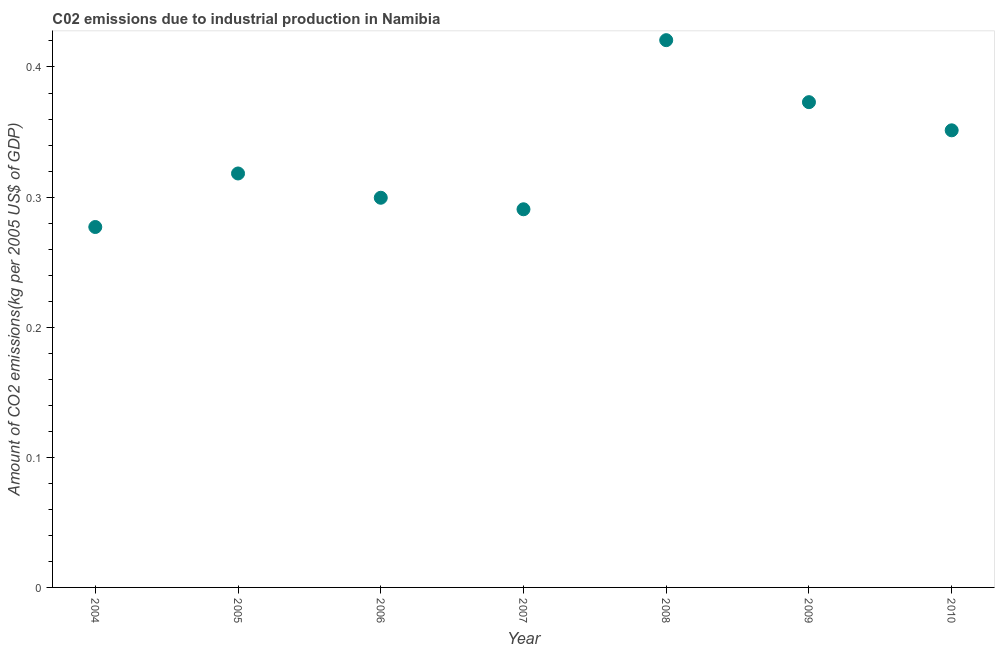What is the amount of co2 emissions in 2007?
Provide a succinct answer. 0.29. Across all years, what is the maximum amount of co2 emissions?
Provide a short and direct response. 0.42. Across all years, what is the minimum amount of co2 emissions?
Your response must be concise. 0.28. In which year was the amount of co2 emissions maximum?
Keep it short and to the point. 2008. In which year was the amount of co2 emissions minimum?
Give a very brief answer. 2004. What is the sum of the amount of co2 emissions?
Your answer should be compact. 2.33. What is the difference between the amount of co2 emissions in 2004 and 2009?
Your answer should be very brief. -0.1. What is the average amount of co2 emissions per year?
Your answer should be very brief. 0.33. What is the median amount of co2 emissions?
Offer a terse response. 0.32. What is the ratio of the amount of co2 emissions in 2004 to that in 2007?
Your answer should be very brief. 0.95. What is the difference between the highest and the second highest amount of co2 emissions?
Offer a very short reply. 0.05. Is the sum of the amount of co2 emissions in 2004 and 2005 greater than the maximum amount of co2 emissions across all years?
Offer a terse response. Yes. What is the difference between the highest and the lowest amount of co2 emissions?
Your answer should be very brief. 0.14. Does the amount of co2 emissions monotonically increase over the years?
Provide a succinct answer. No. What is the title of the graph?
Keep it short and to the point. C02 emissions due to industrial production in Namibia. What is the label or title of the Y-axis?
Keep it short and to the point. Amount of CO2 emissions(kg per 2005 US$ of GDP). What is the Amount of CO2 emissions(kg per 2005 US$ of GDP) in 2004?
Your answer should be compact. 0.28. What is the Amount of CO2 emissions(kg per 2005 US$ of GDP) in 2005?
Make the answer very short. 0.32. What is the Amount of CO2 emissions(kg per 2005 US$ of GDP) in 2006?
Offer a very short reply. 0.3. What is the Amount of CO2 emissions(kg per 2005 US$ of GDP) in 2007?
Make the answer very short. 0.29. What is the Amount of CO2 emissions(kg per 2005 US$ of GDP) in 2008?
Your response must be concise. 0.42. What is the Amount of CO2 emissions(kg per 2005 US$ of GDP) in 2009?
Make the answer very short. 0.37. What is the Amount of CO2 emissions(kg per 2005 US$ of GDP) in 2010?
Your answer should be compact. 0.35. What is the difference between the Amount of CO2 emissions(kg per 2005 US$ of GDP) in 2004 and 2005?
Keep it short and to the point. -0.04. What is the difference between the Amount of CO2 emissions(kg per 2005 US$ of GDP) in 2004 and 2006?
Your answer should be compact. -0.02. What is the difference between the Amount of CO2 emissions(kg per 2005 US$ of GDP) in 2004 and 2007?
Give a very brief answer. -0.01. What is the difference between the Amount of CO2 emissions(kg per 2005 US$ of GDP) in 2004 and 2008?
Ensure brevity in your answer.  -0.14. What is the difference between the Amount of CO2 emissions(kg per 2005 US$ of GDP) in 2004 and 2009?
Ensure brevity in your answer.  -0.1. What is the difference between the Amount of CO2 emissions(kg per 2005 US$ of GDP) in 2004 and 2010?
Provide a succinct answer. -0.07. What is the difference between the Amount of CO2 emissions(kg per 2005 US$ of GDP) in 2005 and 2006?
Give a very brief answer. 0.02. What is the difference between the Amount of CO2 emissions(kg per 2005 US$ of GDP) in 2005 and 2007?
Provide a short and direct response. 0.03. What is the difference between the Amount of CO2 emissions(kg per 2005 US$ of GDP) in 2005 and 2008?
Keep it short and to the point. -0.1. What is the difference between the Amount of CO2 emissions(kg per 2005 US$ of GDP) in 2005 and 2009?
Offer a very short reply. -0.05. What is the difference between the Amount of CO2 emissions(kg per 2005 US$ of GDP) in 2005 and 2010?
Offer a terse response. -0.03. What is the difference between the Amount of CO2 emissions(kg per 2005 US$ of GDP) in 2006 and 2007?
Provide a short and direct response. 0.01. What is the difference between the Amount of CO2 emissions(kg per 2005 US$ of GDP) in 2006 and 2008?
Offer a terse response. -0.12. What is the difference between the Amount of CO2 emissions(kg per 2005 US$ of GDP) in 2006 and 2009?
Offer a terse response. -0.07. What is the difference between the Amount of CO2 emissions(kg per 2005 US$ of GDP) in 2006 and 2010?
Make the answer very short. -0.05. What is the difference between the Amount of CO2 emissions(kg per 2005 US$ of GDP) in 2007 and 2008?
Provide a succinct answer. -0.13. What is the difference between the Amount of CO2 emissions(kg per 2005 US$ of GDP) in 2007 and 2009?
Provide a short and direct response. -0.08. What is the difference between the Amount of CO2 emissions(kg per 2005 US$ of GDP) in 2007 and 2010?
Your response must be concise. -0.06. What is the difference between the Amount of CO2 emissions(kg per 2005 US$ of GDP) in 2008 and 2009?
Provide a short and direct response. 0.05. What is the difference between the Amount of CO2 emissions(kg per 2005 US$ of GDP) in 2008 and 2010?
Make the answer very short. 0.07. What is the difference between the Amount of CO2 emissions(kg per 2005 US$ of GDP) in 2009 and 2010?
Your answer should be very brief. 0.02. What is the ratio of the Amount of CO2 emissions(kg per 2005 US$ of GDP) in 2004 to that in 2005?
Give a very brief answer. 0.87. What is the ratio of the Amount of CO2 emissions(kg per 2005 US$ of GDP) in 2004 to that in 2006?
Offer a terse response. 0.93. What is the ratio of the Amount of CO2 emissions(kg per 2005 US$ of GDP) in 2004 to that in 2007?
Ensure brevity in your answer.  0.95. What is the ratio of the Amount of CO2 emissions(kg per 2005 US$ of GDP) in 2004 to that in 2008?
Offer a terse response. 0.66. What is the ratio of the Amount of CO2 emissions(kg per 2005 US$ of GDP) in 2004 to that in 2009?
Your answer should be very brief. 0.74. What is the ratio of the Amount of CO2 emissions(kg per 2005 US$ of GDP) in 2004 to that in 2010?
Keep it short and to the point. 0.79. What is the ratio of the Amount of CO2 emissions(kg per 2005 US$ of GDP) in 2005 to that in 2006?
Make the answer very short. 1.06. What is the ratio of the Amount of CO2 emissions(kg per 2005 US$ of GDP) in 2005 to that in 2007?
Offer a very short reply. 1.09. What is the ratio of the Amount of CO2 emissions(kg per 2005 US$ of GDP) in 2005 to that in 2008?
Your answer should be very brief. 0.76. What is the ratio of the Amount of CO2 emissions(kg per 2005 US$ of GDP) in 2005 to that in 2009?
Your answer should be very brief. 0.85. What is the ratio of the Amount of CO2 emissions(kg per 2005 US$ of GDP) in 2005 to that in 2010?
Offer a terse response. 0.91. What is the ratio of the Amount of CO2 emissions(kg per 2005 US$ of GDP) in 2006 to that in 2007?
Keep it short and to the point. 1.03. What is the ratio of the Amount of CO2 emissions(kg per 2005 US$ of GDP) in 2006 to that in 2008?
Your answer should be very brief. 0.71. What is the ratio of the Amount of CO2 emissions(kg per 2005 US$ of GDP) in 2006 to that in 2009?
Your answer should be compact. 0.8. What is the ratio of the Amount of CO2 emissions(kg per 2005 US$ of GDP) in 2006 to that in 2010?
Provide a short and direct response. 0.85. What is the ratio of the Amount of CO2 emissions(kg per 2005 US$ of GDP) in 2007 to that in 2008?
Offer a terse response. 0.69. What is the ratio of the Amount of CO2 emissions(kg per 2005 US$ of GDP) in 2007 to that in 2009?
Your response must be concise. 0.78. What is the ratio of the Amount of CO2 emissions(kg per 2005 US$ of GDP) in 2007 to that in 2010?
Keep it short and to the point. 0.83. What is the ratio of the Amount of CO2 emissions(kg per 2005 US$ of GDP) in 2008 to that in 2009?
Keep it short and to the point. 1.13. What is the ratio of the Amount of CO2 emissions(kg per 2005 US$ of GDP) in 2008 to that in 2010?
Your response must be concise. 1.2. What is the ratio of the Amount of CO2 emissions(kg per 2005 US$ of GDP) in 2009 to that in 2010?
Your answer should be compact. 1.06. 